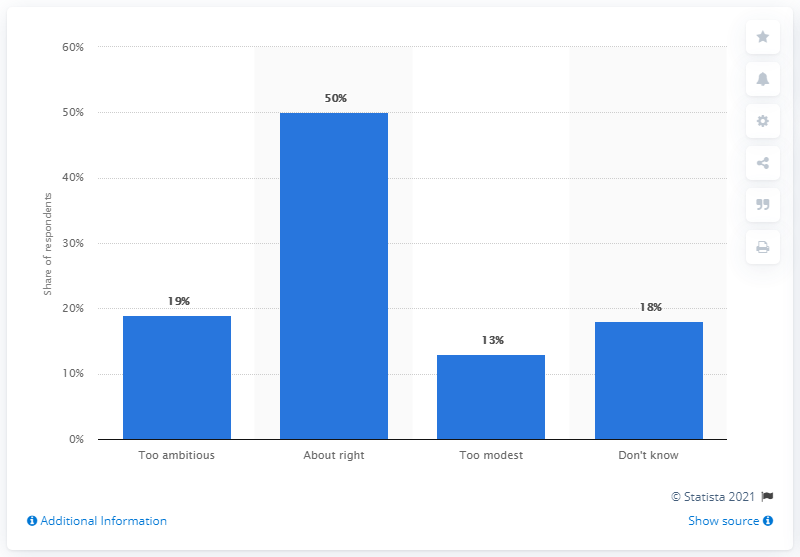Specify some key components in this picture. According to the survey, 19% of respondents believed that the 2020 European Union goal was too ambitious. 